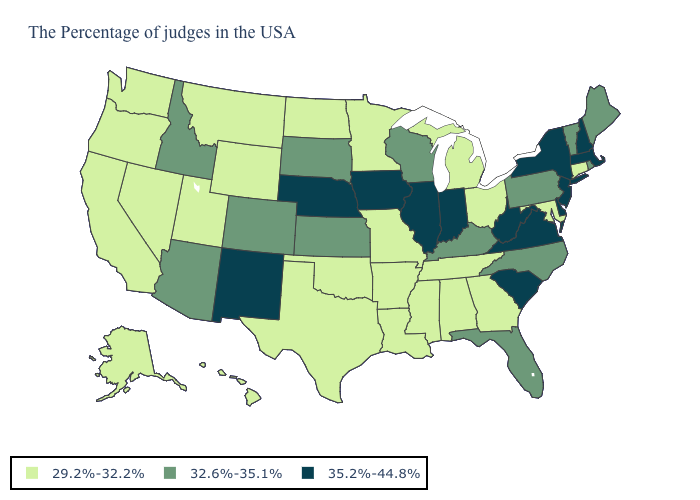Does Utah have the highest value in the West?
Answer briefly. No. Which states have the highest value in the USA?
Concise answer only. Massachusetts, New Hampshire, New York, New Jersey, Delaware, Virginia, South Carolina, West Virginia, Indiana, Illinois, Iowa, Nebraska, New Mexico. Name the states that have a value in the range 29.2%-32.2%?
Short answer required. Connecticut, Maryland, Ohio, Georgia, Michigan, Alabama, Tennessee, Mississippi, Louisiana, Missouri, Arkansas, Minnesota, Oklahoma, Texas, North Dakota, Wyoming, Utah, Montana, Nevada, California, Washington, Oregon, Alaska, Hawaii. Name the states that have a value in the range 35.2%-44.8%?
Quick response, please. Massachusetts, New Hampshire, New York, New Jersey, Delaware, Virginia, South Carolina, West Virginia, Indiana, Illinois, Iowa, Nebraska, New Mexico. Which states have the lowest value in the USA?
Concise answer only. Connecticut, Maryland, Ohio, Georgia, Michigan, Alabama, Tennessee, Mississippi, Louisiana, Missouri, Arkansas, Minnesota, Oklahoma, Texas, North Dakota, Wyoming, Utah, Montana, Nevada, California, Washington, Oregon, Alaska, Hawaii. What is the value of Kansas?
Keep it brief. 32.6%-35.1%. Which states have the highest value in the USA?
Write a very short answer. Massachusetts, New Hampshire, New York, New Jersey, Delaware, Virginia, South Carolina, West Virginia, Indiana, Illinois, Iowa, Nebraska, New Mexico. What is the value of Arizona?
Be succinct. 32.6%-35.1%. Is the legend a continuous bar?
Short answer required. No. What is the lowest value in the West?
Short answer required. 29.2%-32.2%. Does the first symbol in the legend represent the smallest category?
Concise answer only. Yes. Does the first symbol in the legend represent the smallest category?
Give a very brief answer. Yes. Is the legend a continuous bar?
Write a very short answer. No. What is the lowest value in the Northeast?
Write a very short answer. 29.2%-32.2%. Does Delaware have the lowest value in the South?
Quick response, please. No. 